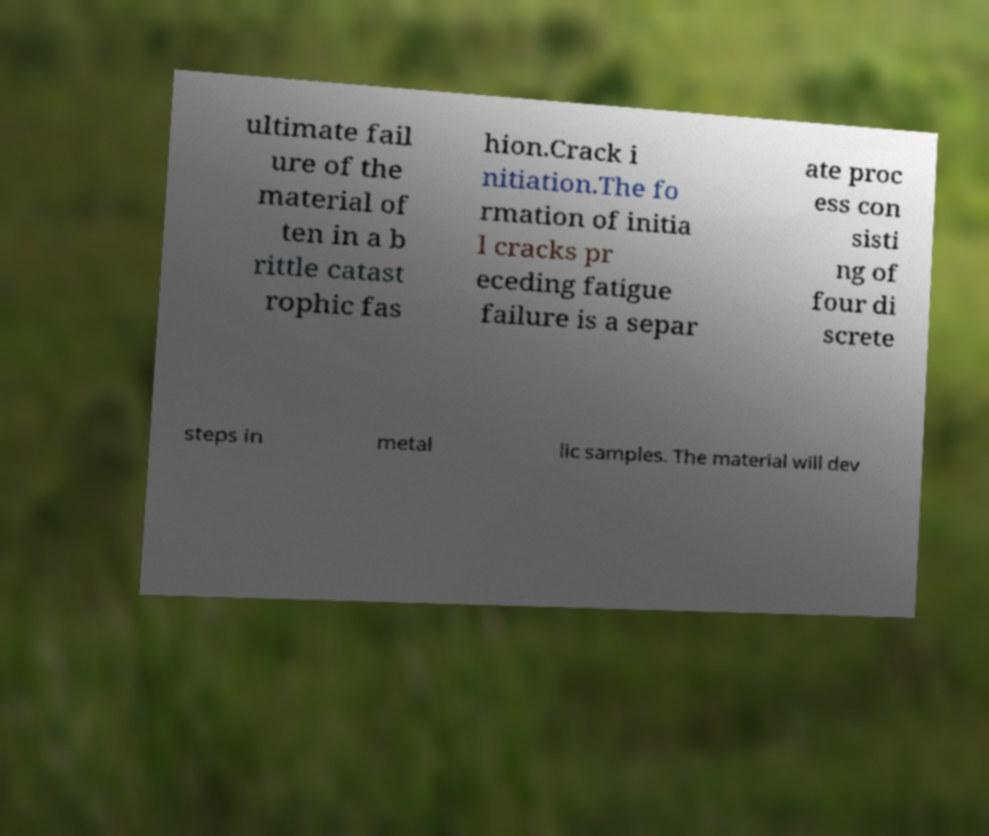I need the written content from this picture converted into text. Can you do that? ultimate fail ure of the material of ten in a b rittle catast rophic fas hion.Crack i nitiation.The fo rmation of initia l cracks pr eceding fatigue failure is a separ ate proc ess con sisti ng of four di screte steps in metal lic samples. The material will dev 